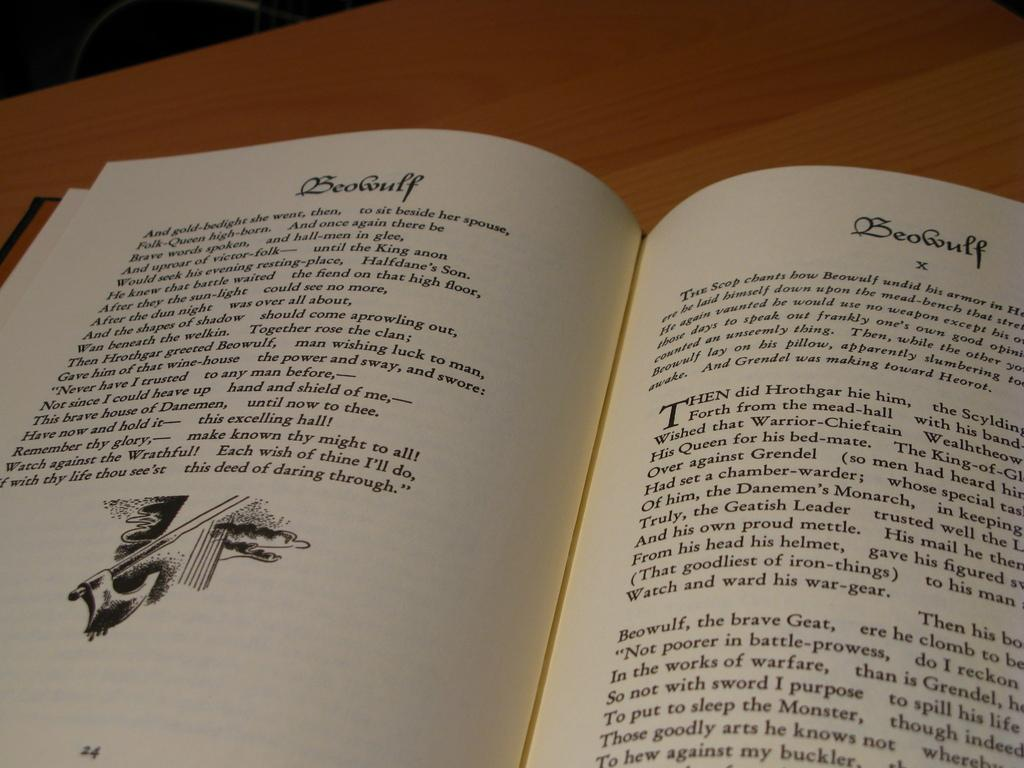Provide a one-sentence caption for the provided image. A book is open on a table displaying the story of Beowulf. 